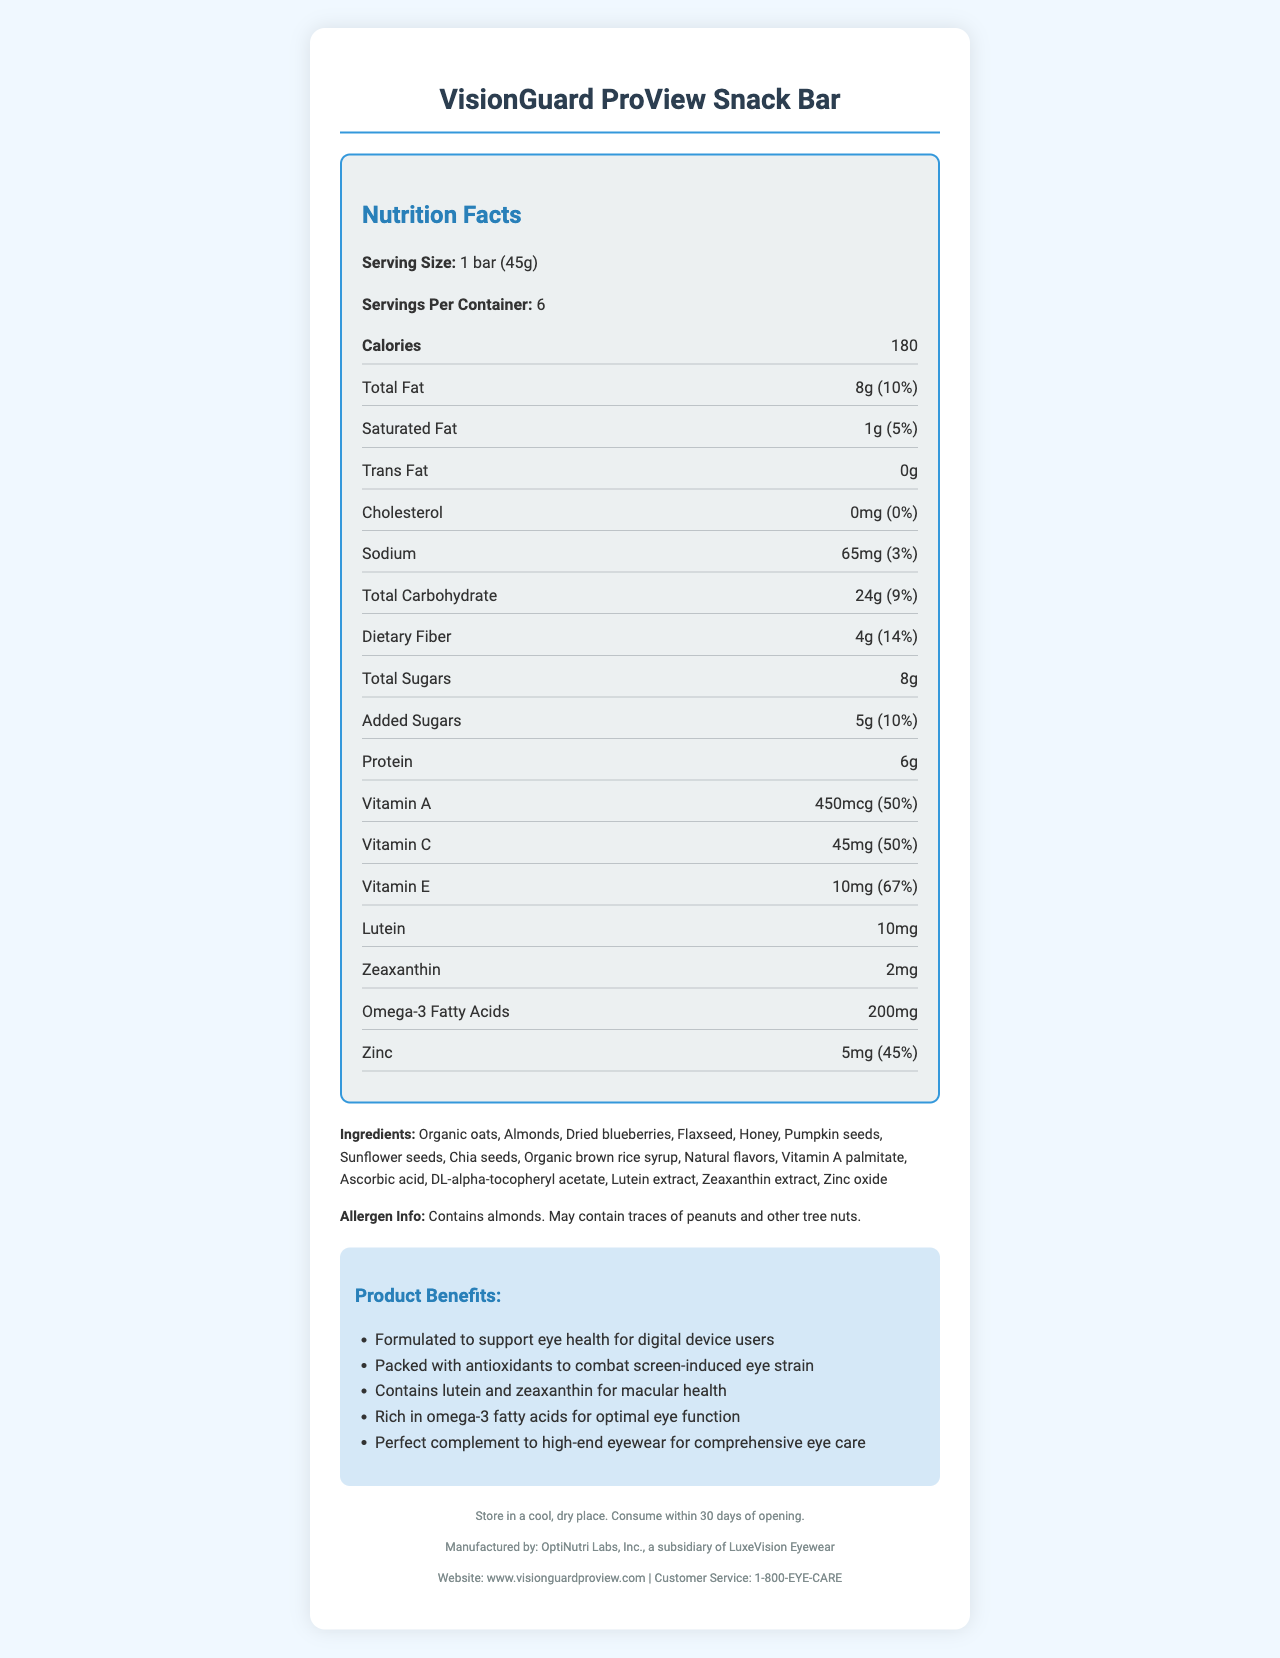how many servings are there per container? The document states that there are 6 servings per container for the VisionGuard ProView Snack Bar.
Answer: 6 what is the calorie count per serving? Each serving of the snack bar provides 180 calories as stated in the document.
Answer: 180 how much total fat is there per serving? The total fat per serving is listed as 8g.
Answer: 8g what percentage of daily value does the dietary fiber content provide? The dietary fiber content provides 14% of the daily value per serving.
Answer: 14% does this product contain any trans fat? The document specifies that the trans fat content is 0g.
Answer: No which vitamin contributes the highest percentage of the daily value? A. Vitamin A B. Vitamin C C. Vitamin E Vitamin E provides 67% of the daily value, which is higher than the percentages for Vitamin A (50%) and Vitamin C (50%).
Answer: C what are the two main antioxidants mentioned in the marketing claims for eye health? A. Lutein and Vitamin C B. Vitamin E and Zeaxanthin C. Lutein and Zeaxanthin D. Vitamin A and Omega-3 The marketing claims specifically highlight that the product contains lutein and zeaxanthin for macular health.
Answer: C is this product suitable for someone with a peanut allergy? The allergen information states that the product contains almonds and may contain traces of peanuts and other tree nuts, meaning it's not guaranteed to be peanut-free.
Answer: Maybe describe the main purpose of the VisionGuard ProView Snack Bar The for brief summary explanation of the product shows nutritional concerns for those who frequently use screens by offering a snack with added ingredients that protect eye health alongside high-end eyewear.
Answer: The main purpose of the VisionGuard ProView Snack Bar is to support eye health for digital device users by providing a range of nutrients, including antioxidants, lutein, and zeaxanthin, that combat screen-induced eye strain and promote macular health. It is also rich in omega-3 fatty acids and adheres to high-end eyewear for comprehensive eye care. what is the exact amount of zinc per serving? The document specifies that each serving contains 5mg of zinc.
Answer: 5mg what are the two main reasons given for promoting the product in the marketing claims? The marketing claims highlight reducing screen-induced eye strain through antioxidants and supporting macular health through lutein and zeaxanthin.
Answer: Reducing screen-induced eye strain, Supporting macular health what are the sources of omega-3 fatty acids in this snack bar? The document lists the total omega-3 fatty acids amount but does not specify their sources.
Answer: Not enough information what are the main ingredients used in the VisionGuard ProView Snack Bar? The document lists these ingredients specifically in the ingredients section.
Answer: Organic oats, Almonds, Dried blueberries, Flaxseed, Honey, Pumpkin seeds, Sunflower seeds, Chia seeds, Organic brown rice syrup, Natural flavors, Vitamin A palmitate, Ascorbic acid, DL-alpha-tocopheryl acetate, Lutein extract, Zeaxanthin extract, Zinc oxide what is the recommended storage instruction for this snack bar? The storage instructions are clearly stated in the document.
Answer: Store in a cool, dry place. Consume within 30 days of opening. 